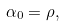Convert formula to latex. <formula><loc_0><loc_0><loc_500><loc_500>\alpha _ { 0 } = \rho ,</formula> 